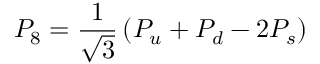<formula> <loc_0><loc_0><loc_500><loc_500>P _ { 8 } = { \frac { 1 } { \sqrt { 3 } } } \left ( P _ { u } + P _ { d } - 2 P _ { s } \right )</formula> 